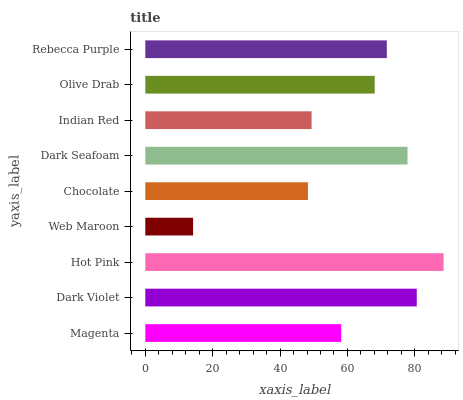Is Web Maroon the minimum?
Answer yes or no. Yes. Is Hot Pink the maximum?
Answer yes or no. Yes. Is Dark Violet the minimum?
Answer yes or no. No. Is Dark Violet the maximum?
Answer yes or no. No. Is Dark Violet greater than Magenta?
Answer yes or no. Yes. Is Magenta less than Dark Violet?
Answer yes or no. Yes. Is Magenta greater than Dark Violet?
Answer yes or no. No. Is Dark Violet less than Magenta?
Answer yes or no. No. Is Olive Drab the high median?
Answer yes or no. Yes. Is Olive Drab the low median?
Answer yes or no. Yes. Is Dark Seafoam the high median?
Answer yes or no. No. Is Indian Red the low median?
Answer yes or no. No. 